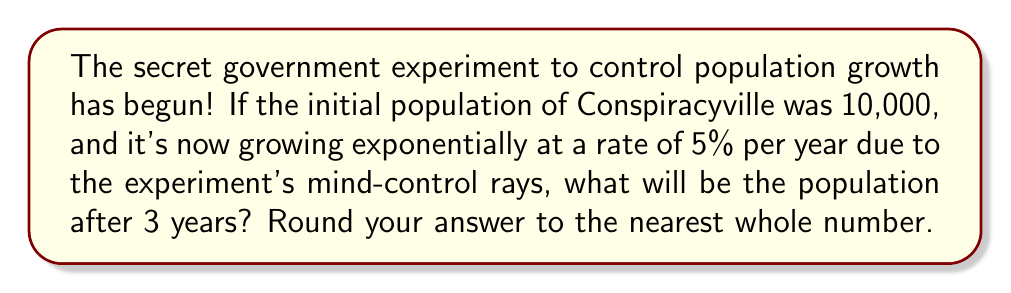Can you solve this math problem? Let's uncover the truth about this population growth!

1) The formula for exponential growth is:
   $$A = P(1 + r)^t$$
   Where:
   $A$ = Final amount
   $P$ = Initial principal (starting population)
   $r$ = Growth rate (as a decimal)
   $t$ = Time period

2) We know:
   $P = 10,000$ (initial population)
   $r = 0.05$ (5% growth rate)
   $t = 3$ years

3) Let's plug these into our formula:
   $$A = 10,000(1 + 0.05)^3$$

4) Simplify inside the parentheses:
   $$A = 10,000(1.05)^3$$

5) Calculate the exponent:
   $$A = 10,000(1.157625)$$

6) Multiply:
   $$A = 11,576.25$$

7) Rounding to the nearest whole number:
   $$A ≈ 11,576$$

The mind-control rays are working! The population has increased significantly!
Answer: 11,576 